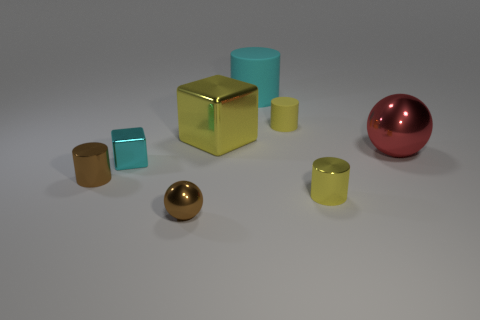Do the small matte object and the large cyan thing have the same shape?
Give a very brief answer. Yes. What material is the yellow object on the right side of the small matte thing on the right side of the cyan metallic thing made of?
Give a very brief answer. Metal. What material is the other object that is the same color as the big rubber object?
Your response must be concise. Metal. Do the cyan matte cylinder and the red thing have the same size?
Your response must be concise. Yes. Are there any yellow cylinders that are left of the yellow matte cylinder on the left side of the big red object?
Your response must be concise. No. The metallic cylinder that is the same color as the tiny rubber thing is what size?
Your answer should be very brief. Small. What shape is the cyan object that is behind the red metallic object?
Offer a terse response. Cylinder. What number of things are left of the small metal cylinder left of the small metal cylinder right of the brown cylinder?
Give a very brief answer. 0. There is a brown shiny cylinder; is it the same size as the metallic cube that is behind the big shiny ball?
Keep it short and to the point. No. What is the size of the brown object that is left of the metallic block that is in front of the red thing?
Keep it short and to the point. Small. 